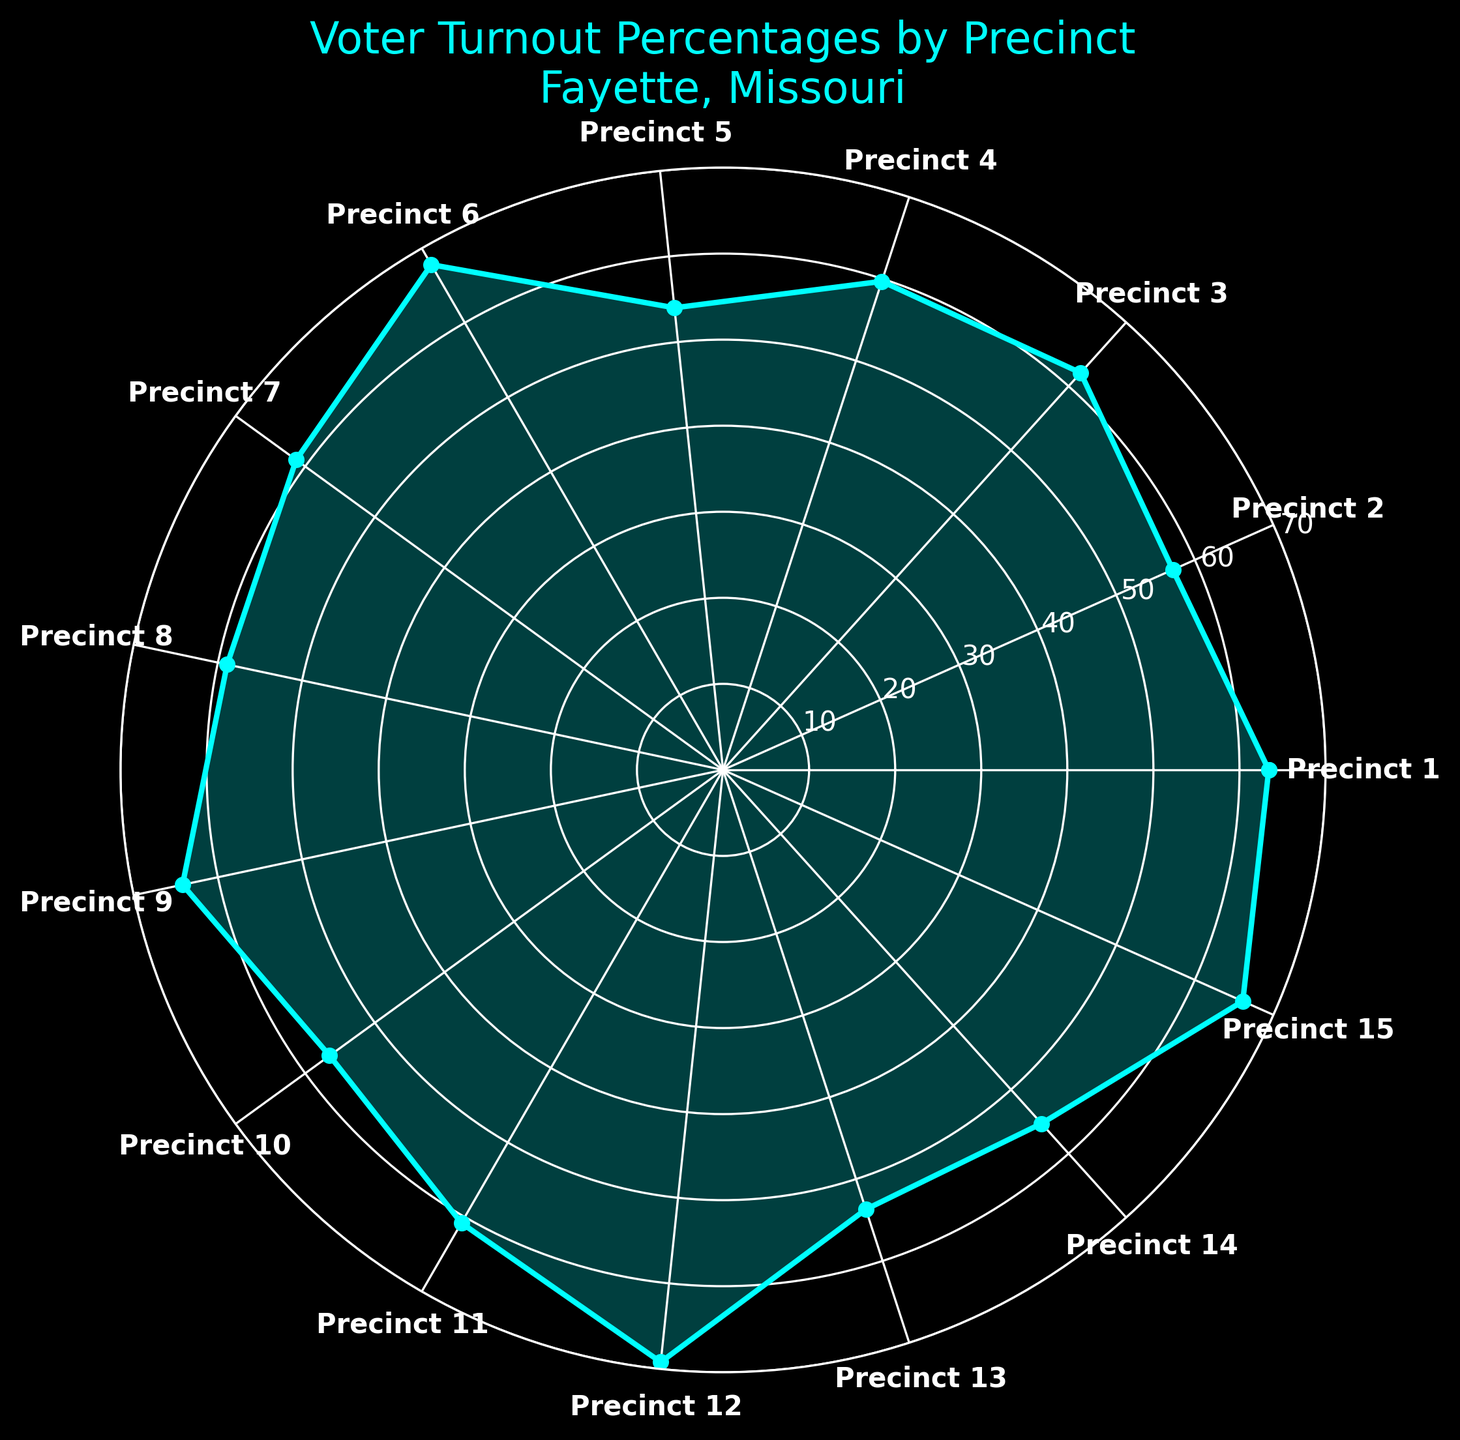Which precinct has the highest voter turnout percentage? To find the highest voter turnout percentage, look at the values on the plot that represent each precinct. Precinct 12 has the highest value with 69.2%.
Answer: Precinct 12 Which precinct shows the lowest voter turnout percentage? The lowest turnout percentage can be identified by looking at the smallest value on the plot. Precinct 13 has the lowest turnout at 53.7%.
Answer: Precinct 13 What's the average voter turnout percentage across all precincts? Add all the turnout percentages and divide by the number of precincts: (63.4 + 57.2 + 62.1 + 59.7 + 54.0 + 67.8 + 61.3 + 58.9 + 64.2 + 56.5 + 60.8 + 69.2 + 53.7 + 55.3 + 66.1) / 15 = 61.05%
Answer: 61.05% How does Precinct 6 compare to Precinct 15 in terms of voter turnout percentage? Compare the turnout percentages directly. Precinct 6 has a turnout of 67.8%, while Precinct 15 has a turnout of 66.1%.
Answer: Precinct 6 has a higher turnout Is the turnout percentage of Precinct 10 above or below 60%? By checking the value on the plot for Precinct 10, we see it is 56.5%, which is below 60%.
Answer: Below Which three precincts have turnout percentages closest to 60%? Identify the precincts around 60%: Precinct 2 (57.2%), Precinct 4 (59.7%), and Precinct 11 (60.8%).
Answer: Precincts 2, 4, and 11 By how much does the voter turnout percentage in Precinct 9 exceed that of Precinct 5? Subtract the percentage of Precinct 5 from that of Precinct 9: 64.2% - 54.0% = 10.2%.
Answer: 10.2% What is the total turnout percentage for Precincts 7, 8, and 9 combined? Add the percentages for Precincts 7, 8, and 9: 61.3% + 58.9% + 64.2% = 184.4%.
Answer: 184.4% How many precincts have a turnout percentage greater than 60%? Count the number of precincts with percentages above 60: Precincts 1, 3, 6, 7, 9, 11, 12, and 15, which totals 8 precincts.
Answer: 8 precincts 